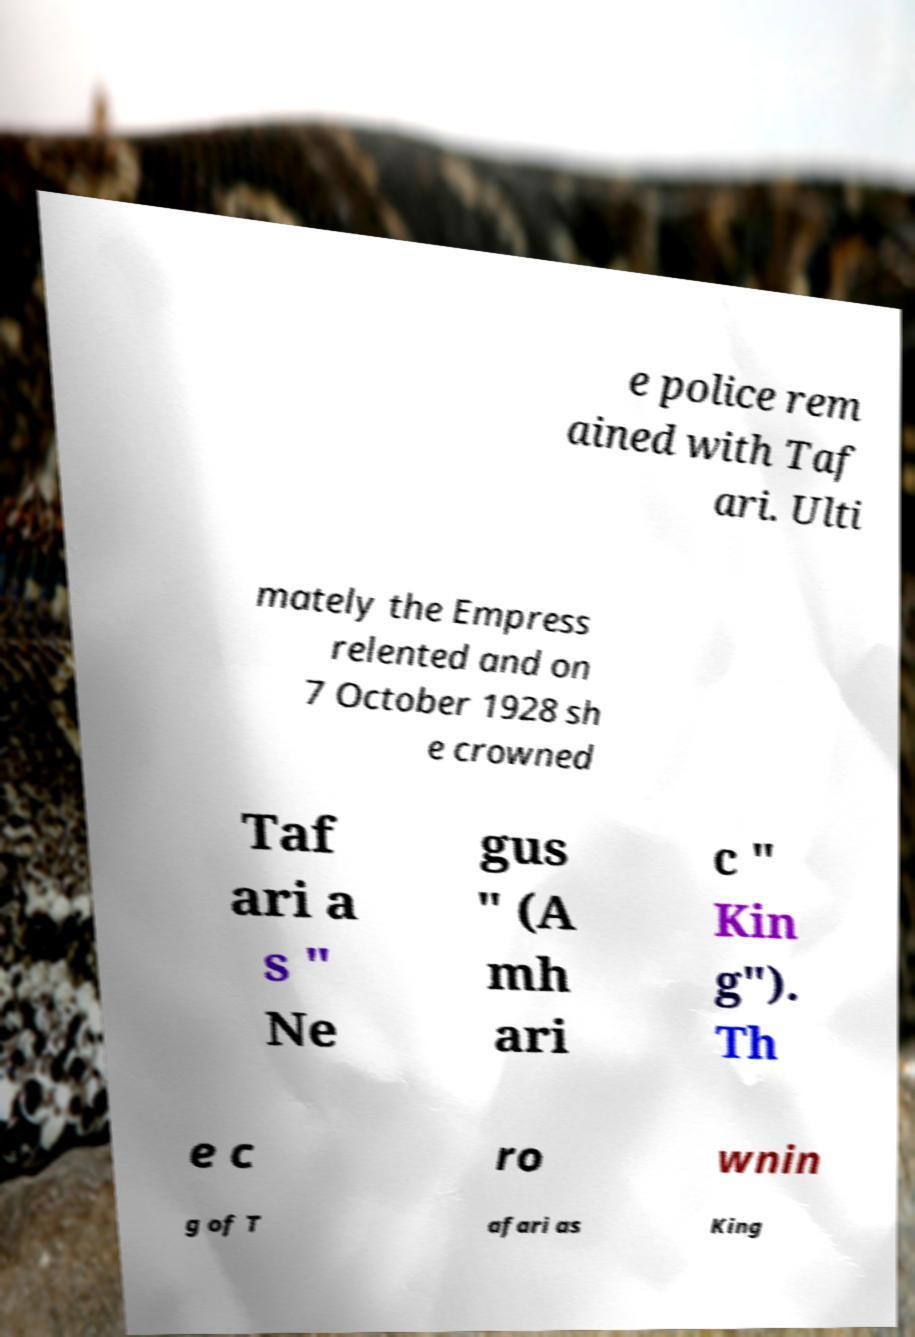Could you assist in decoding the text presented in this image and type it out clearly? e police rem ained with Taf ari. Ulti mately the Empress relented and on 7 October 1928 sh e crowned Taf ari a s " Ne gus " (A mh ari c " Kin g"). Th e c ro wnin g of T afari as King 